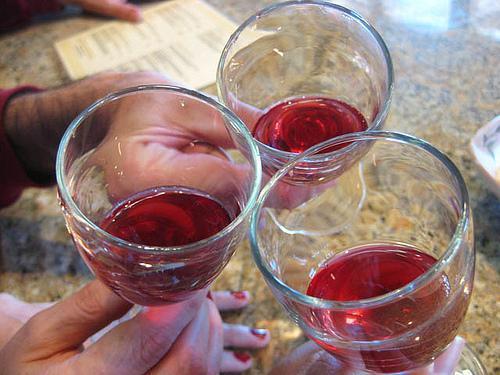How many glasses are there?
Give a very brief answer. 3. How many people can you see?
Give a very brief answer. 2. How many wine glasses are there?
Give a very brief answer. 2. How many different types of boats are seen?
Give a very brief answer. 0. 